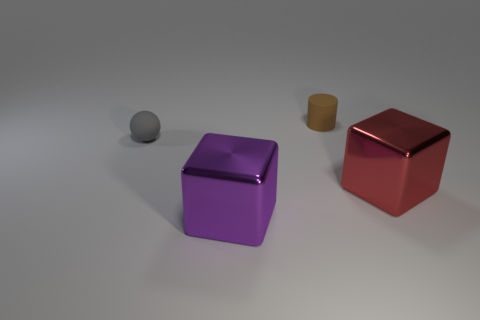What number of large purple metal things have the same shape as the big red shiny thing? 1 